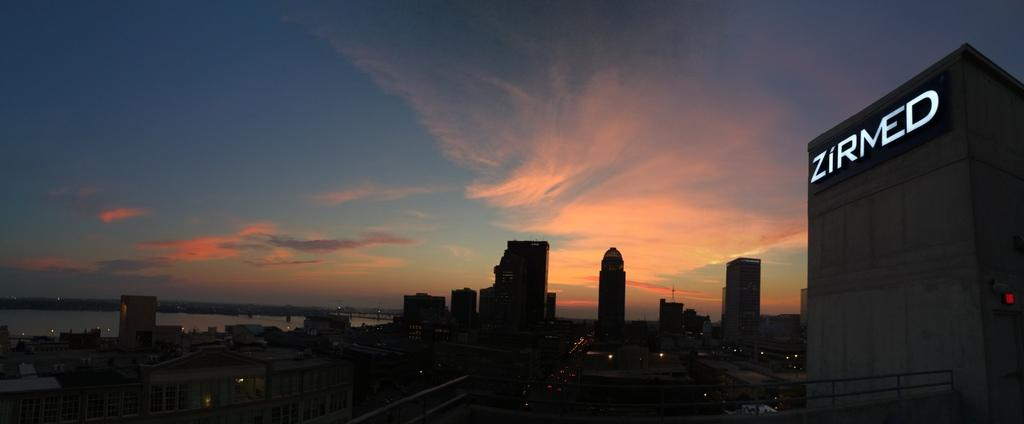What type of structures can be seen in the image? There are buildings in the image. What natural feature is on the left side of the image? There is a river on the left side of the image. What is visible in the background of the image? The sky is visible in the background of the image. Can you tell me how many toothbrushes are floating in the river in the image? There are no toothbrushes present in the image, and therefore no such activity can be observed. Is the brother of the person taking the picture visible in the image? There is no reference to a person taking the picture or their brother in the image, so it is not possible to answer that question. 